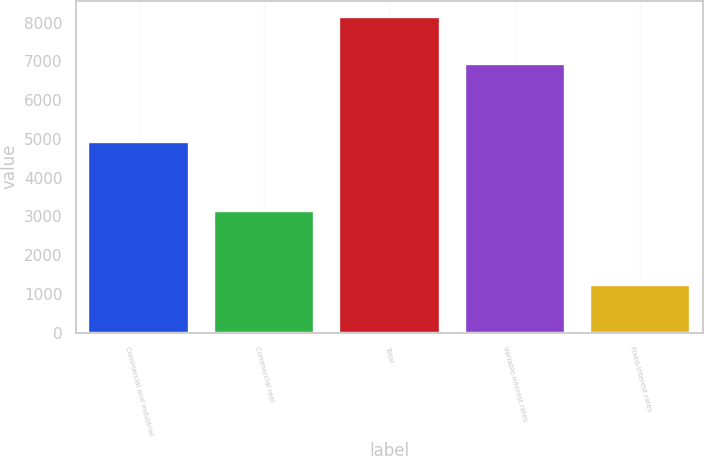Convert chart. <chart><loc_0><loc_0><loc_500><loc_500><bar_chart><fcel>Commercial and industrial<fcel>Commercial real<fcel>Total<fcel>Variable-interest rates<fcel>Fixed-interest rates<nl><fcel>4932<fcel>3148<fcel>8156<fcel>6925<fcel>1231<nl></chart> 